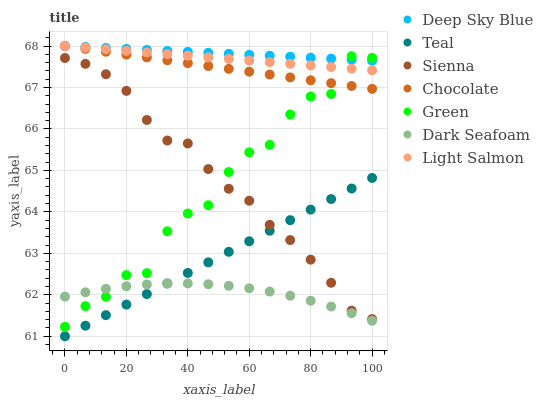Does Dark Seafoam have the minimum area under the curve?
Answer yes or no. Yes. Does Deep Sky Blue have the maximum area under the curve?
Answer yes or no. Yes. Does Chocolate have the minimum area under the curve?
Answer yes or no. No. Does Chocolate have the maximum area under the curve?
Answer yes or no. No. Is Deep Sky Blue the smoothest?
Answer yes or no. Yes. Is Green the roughest?
Answer yes or no. Yes. Is Chocolate the smoothest?
Answer yes or no. No. Is Chocolate the roughest?
Answer yes or no. No. Does Teal have the lowest value?
Answer yes or no. Yes. Does Chocolate have the lowest value?
Answer yes or no. No. Does Chocolate have the highest value?
Answer yes or no. Yes. Does Sienna have the highest value?
Answer yes or no. No. Is Sienna less than Deep Sky Blue?
Answer yes or no. Yes. Is Deep Sky Blue greater than Sienna?
Answer yes or no. Yes. Does Sienna intersect Green?
Answer yes or no. Yes. Is Sienna less than Green?
Answer yes or no. No. Is Sienna greater than Green?
Answer yes or no. No. Does Sienna intersect Deep Sky Blue?
Answer yes or no. No. 